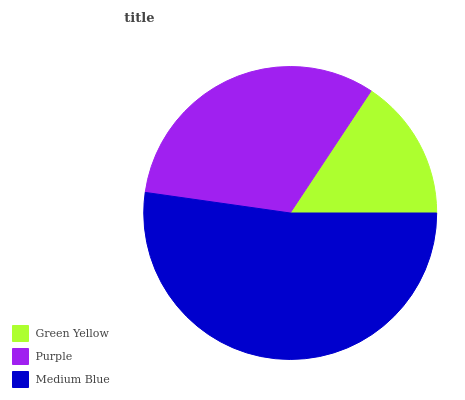Is Green Yellow the minimum?
Answer yes or no. Yes. Is Medium Blue the maximum?
Answer yes or no. Yes. Is Purple the minimum?
Answer yes or no. No. Is Purple the maximum?
Answer yes or no. No. Is Purple greater than Green Yellow?
Answer yes or no. Yes. Is Green Yellow less than Purple?
Answer yes or no. Yes. Is Green Yellow greater than Purple?
Answer yes or no. No. Is Purple less than Green Yellow?
Answer yes or no. No. Is Purple the high median?
Answer yes or no. Yes. Is Purple the low median?
Answer yes or no. Yes. Is Medium Blue the high median?
Answer yes or no. No. Is Green Yellow the low median?
Answer yes or no. No. 